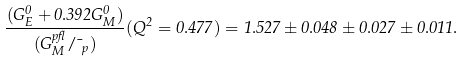<formula> <loc_0><loc_0><loc_500><loc_500>\frac { ( G _ { E } ^ { 0 } + 0 . 3 9 2 G _ { M } ^ { 0 } ) } { ( G _ { M } ^ { p \gamma } / \mu _ { p } ) } ( Q ^ { 2 } = 0 . 4 7 7 ) = 1 . 5 2 7 \pm 0 . 0 4 8 \pm 0 . 0 2 7 \pm 0 . 0 1 1 .</formula> 